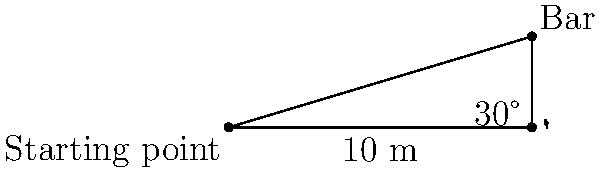As an athlete preparing for the high jump event in the ASEAN Para Games, you're analyzing the setup. The high jump bar is positioned 10 meters away from your starting point. You observe that the angle of elevation from the ground to the top of the bar is 30°. What is the height of the high jump bar to the nearest centimeter? Let's approach this step-by-step using trigonometry:

1) We can visualize this as a right-angled triangle where:
   - The base of the triangle is the distance from the starting point to the bar (10 meters)
   - The height of the triangle is the height of the bar (what we're trying to find)
   - The angle of elevation is 30°

2) In this right-angled triangle, we know:
   - The adjacent side (base) = 10 meters
   - The angle = 30°
   - We need to find the opposite side (height)

3) The trigonometric ratio that relates the opposite side to the adjacent side is the tangent (tan):

   $$\tan \theta = \frac{\text{opposite}}{\text{adjacent}}$$

4) Substituting our known values:

   $$\tan 30° = \frac{\text{height}}{10}$$

5) Rearranging to solve for height:

   $$\text{height} = 10 \times \tan 30°$$

6) We know that $\tan 30° = \frac{1}{\sqrt{3}} \approx 0.5773$

7) Therefore:

   $$\text{height} = 10 \times 0.5773 = 5.773 \text{ meters}$$

8) Converting to centimeters and rounding to the nearest centimeter:

   $$5.773 \text{ m} = 577.3 \text{ cm} \approx 577 \text{ cm}$$

Thus, the height of the high jump bar is approximately 577 cm.
Answer: 577 cm 